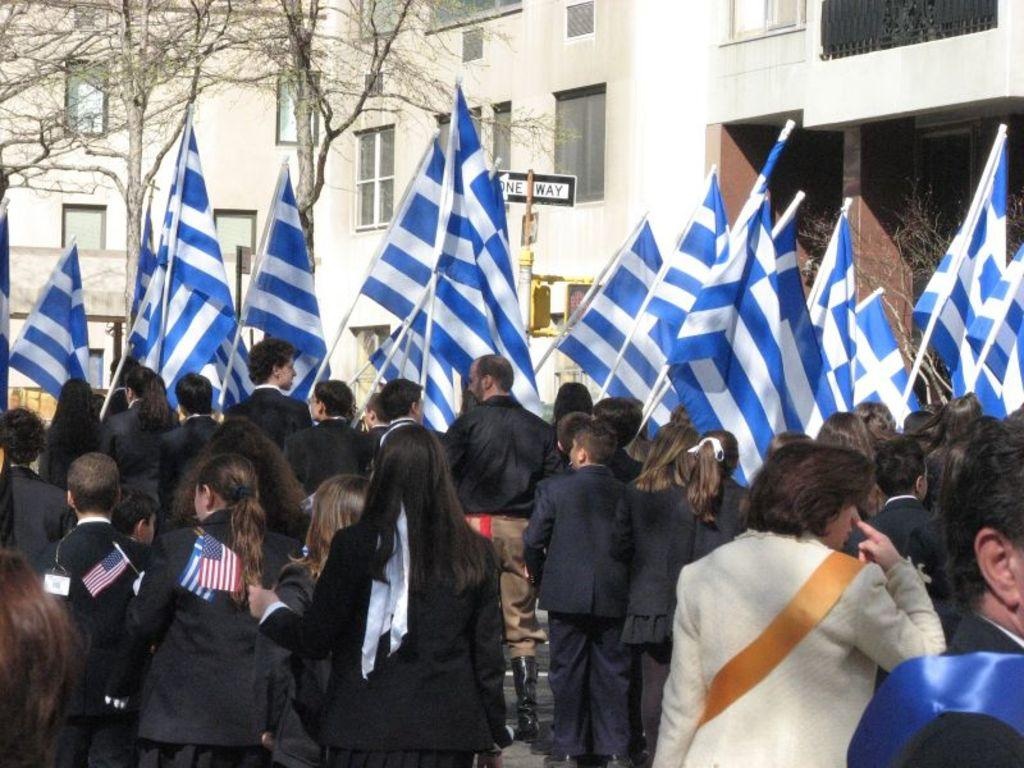What can be seen in the foreground of the image? There are people standing in the foreground of the image. What are the people holding in the image? The people are holding flags. What type of natural scenery is visible in the background of the image? There are trees in the background of the image. What type of man-made structures can be seen in the background of the image? There are buildings in the background of the image. What additional object is visible in the image? There is a signboard visible in the image. Can you describe the harbor in the image? There is no harbor present in the image. What type of crops can be seen growing in the field in the image? There is no field present in the image. 